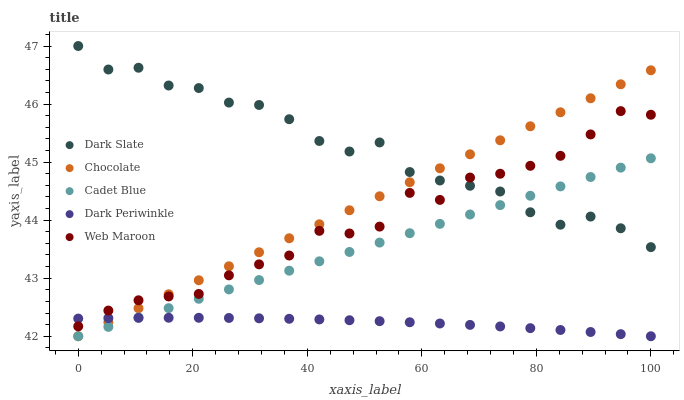Does Dark Periwinkle have the minimum area under the curve?
Answer yes or no. Yes. Does Dark Slate have the maximum area under the curve?
Answer yes or no. Yes. Does Cadet Blue have the minimum area under the curve?
Answer yes or no. No. Does Cadet Blue have the maximum area under the curve?
Answer yes or no. No. Is Chocolate the smoothest?
Answer yes or no. Yes. Is Dark Slate the roughest?
Answer yes or no. Yes. Is Cadet Blue the smoothest?
Answer yes or no. No. Is Cadet Blue the roughest?
Answer yes or no. No. Does Cadet Blue have the lowest value?
Answer yes or no. Yes. Does Web Maroon have the lowest value?
Answer yes or no. No. Does Dark Slate have the highest value?
Answer yes or no. Yes. Does Cadet Blue have the highest value?
Answer yes or no. No. Is Dark Periwinkle less than Dark Slate?
Answer yes or no. Yes. Is Web Maroon greater than Cadet Blue?
Answer yes or no. Yes. Does Web Maroon intersect Chocolate?
Answer yes or no. Yes. Is Web Maroon less than Chocolate?
Answer yes or no. No. Is Web Maroon greater than Chocolate?
Answer yes or no. No. Does Dark Periwinkle intersect Dark Slate?
Answer yes or no. No. 